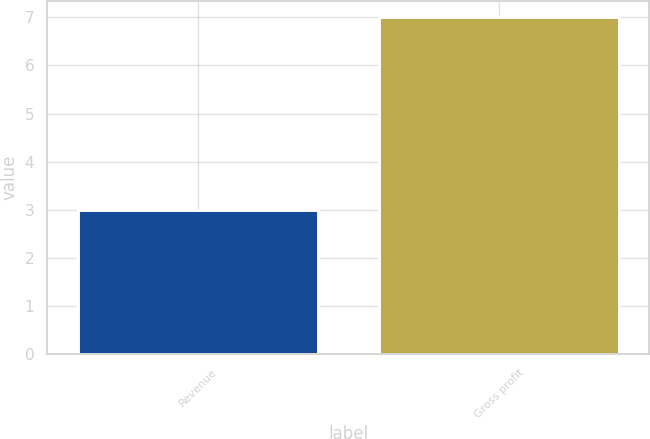Convert chart to OTSL. <chart><loc_0><loc_0><loc_500><loc_500><bar_chart><fcel>Revenue<fcel>Gross profit<nl><fcel>3<fcel>7<nl></chart> 